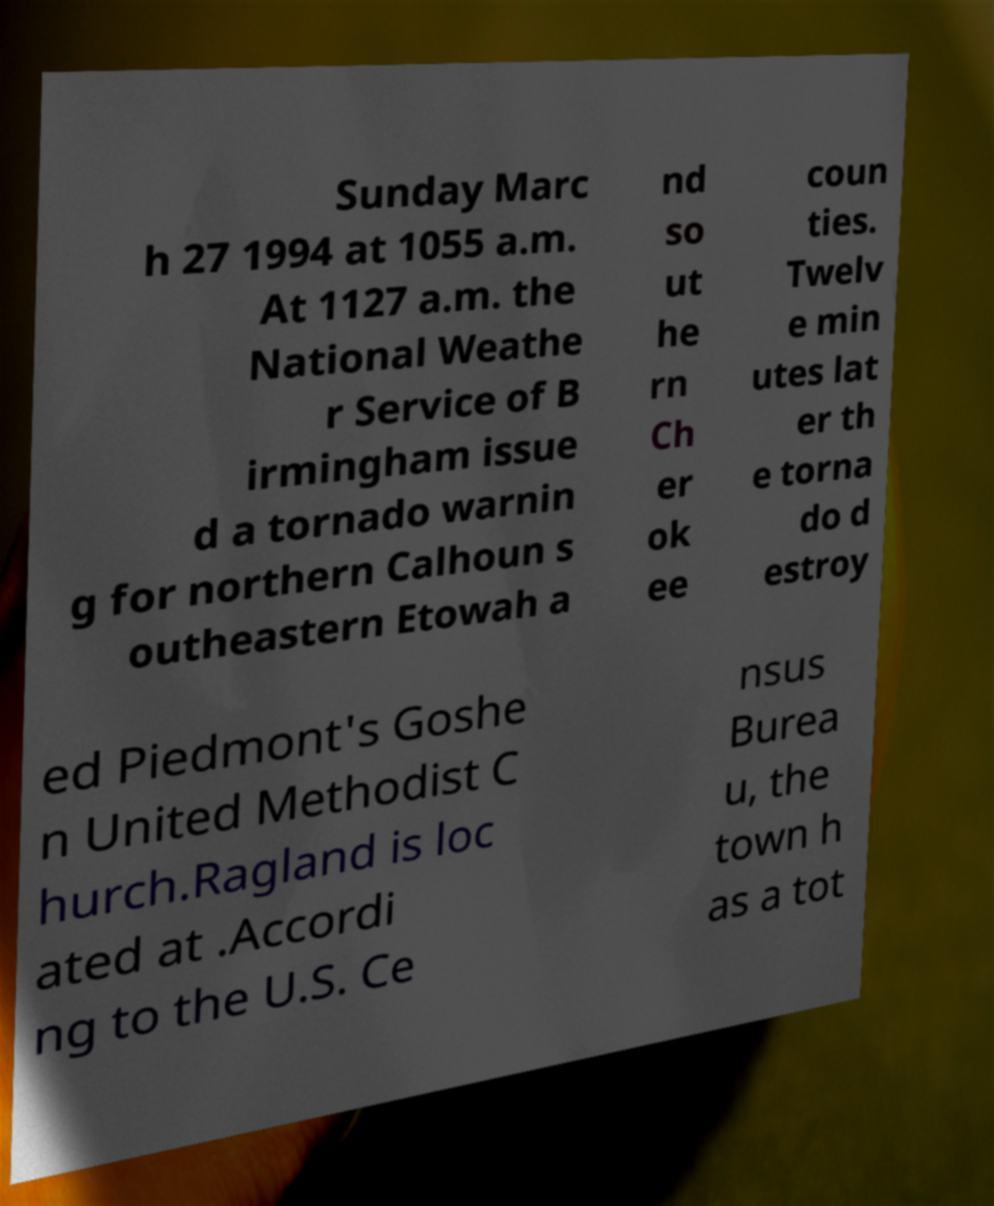Can you accurately transcribe the text from the provided image for me? Sunday Marc h 27 1994 at 1055 a.m. At 1127 a.m. the National Weathe r Service of B irmingham issue d a tornado warnin g for northern Calhoun s outheastern Etowah a nd so ut he rn Ch er ok ee coun ties. Twelv e min utes lat er th e torna do d estroy ed Piedmont's Goshe n United Methodist C hurch.Ragland is loc ated at .Accordi ng to the U.S. Ce nsus Burea u, the town h as a tot 